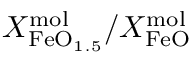Convert formula to latex. <formula><loc_0><loc_0><loc_500><loc_500>X _ { F e O _ { 1 . 5 } } ^ { m o l } / X _ { F e O } ^ { m o l }</formula> 